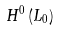<formula> <loc_0><loc_0><loc_500><loc_500>H ^ { 0 } \left ( L _ { 0 } \right )</formula> 